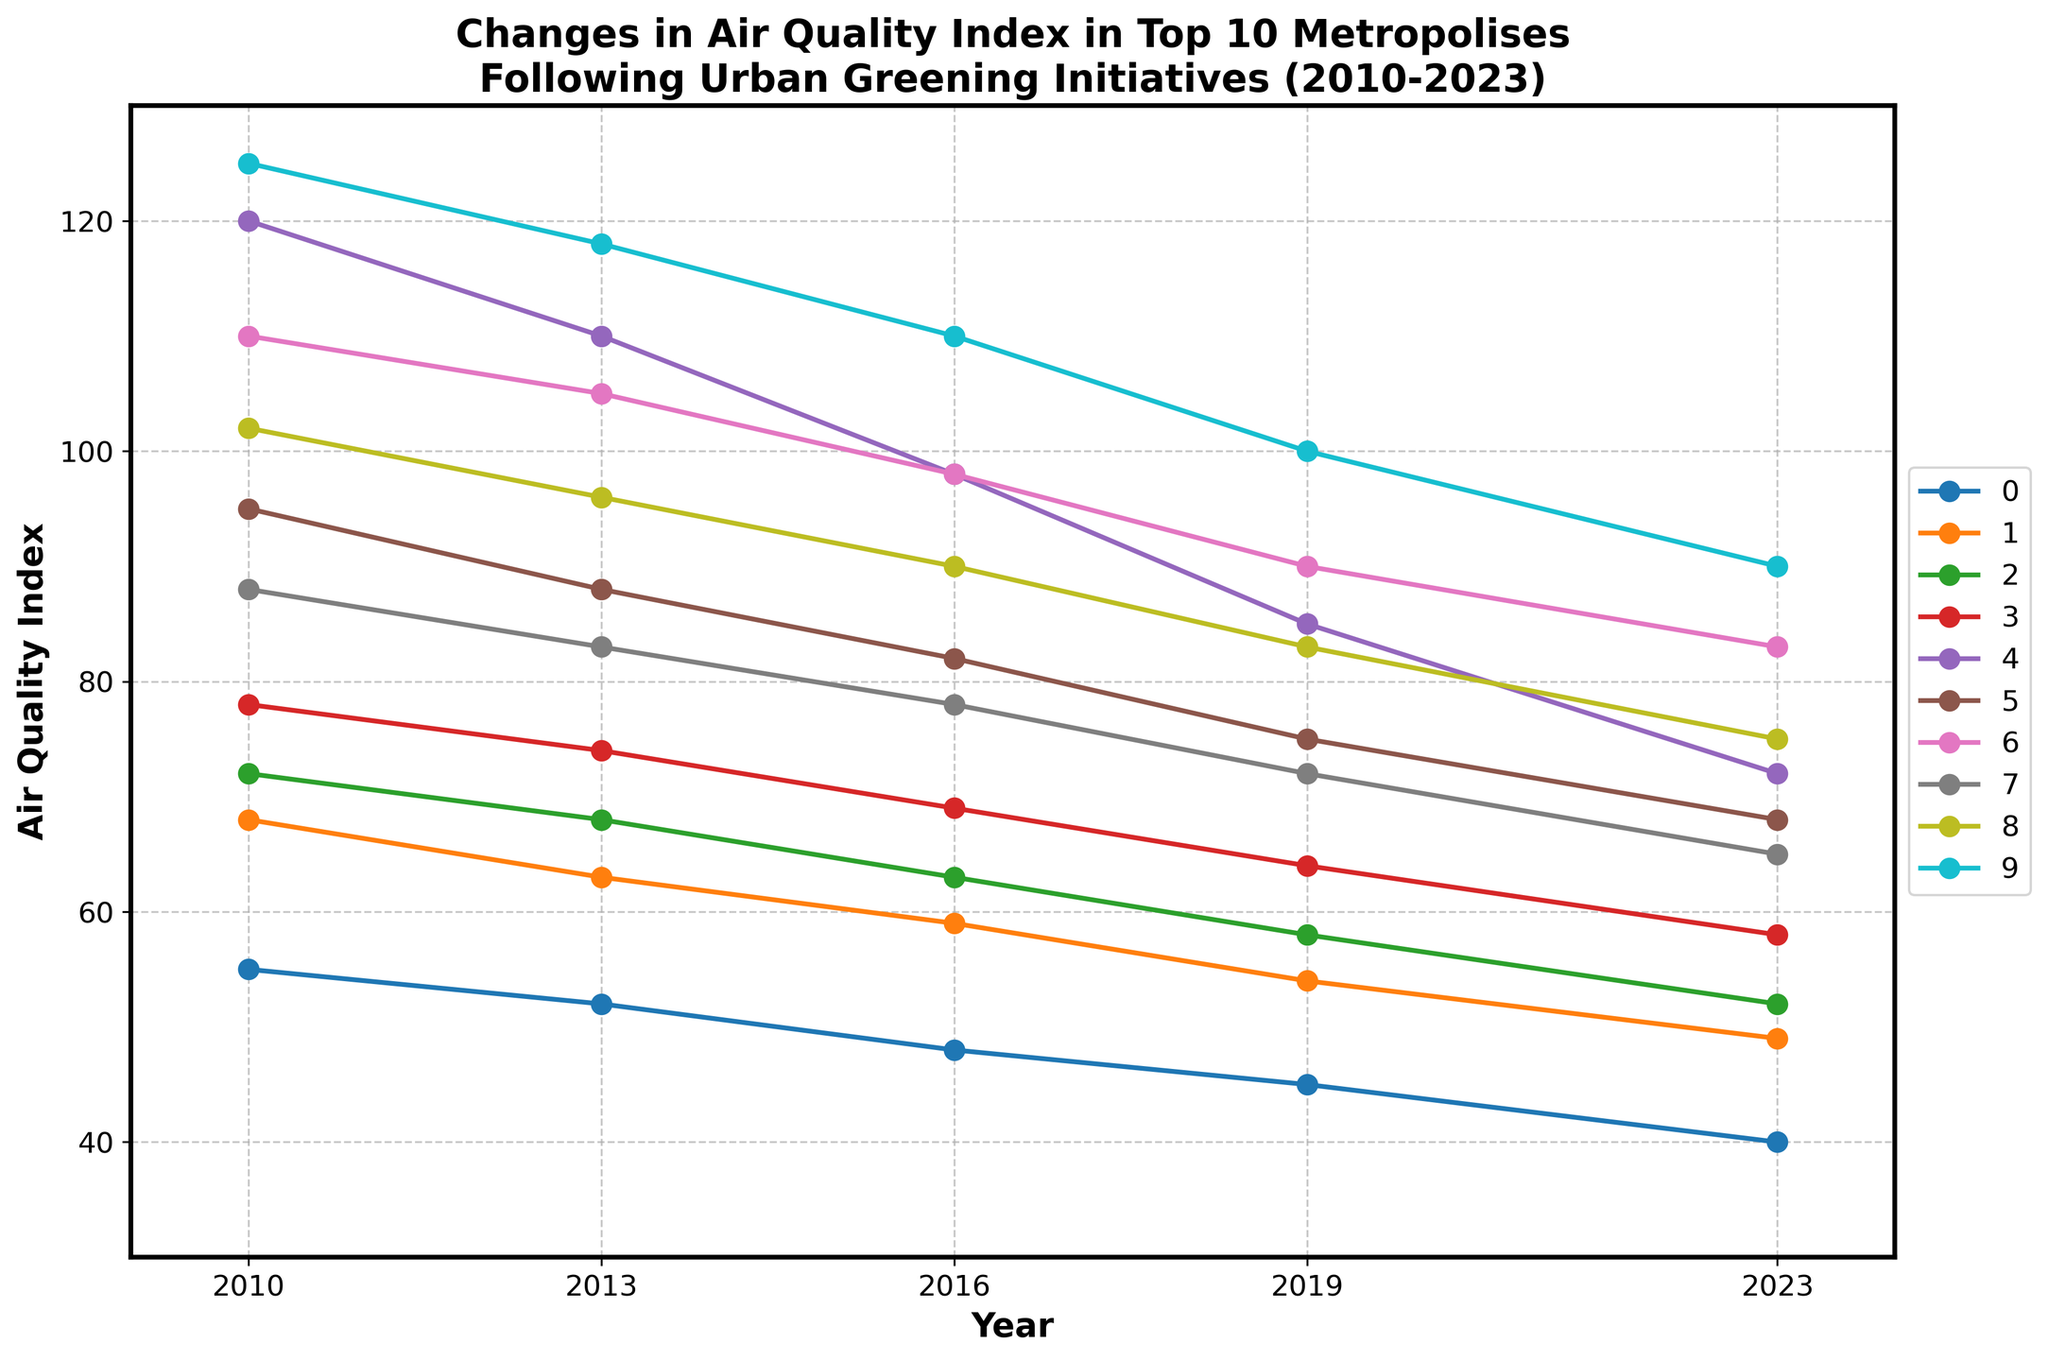Which city shows the most significant improvement in air quality index from 2010 to 2023? By analyzing the figure, find the largest difference in the air quality index between 2010 and 2023. Compare these differences for all cities.
Answer: Delhi Which city had the highest air quality index in 2010 and what was its value? Look for the tallest line at the 2010 mark on the figure. The city with the highest line represents the highest air quality index in 2010.
Answer: Delhi, 125 Which city had the lowest air quality index in 2023? Find the shortest line at the 2023 mark on the figure. The city with the lowest line represents the lowest air quality index in 2023.
Answer: Tokyo What is the difference in air quality index between Paris and São Paulo in 2023? Locate the values for Paris and São Paulo at the 2023 mark and subtract the smaller value from the larger value.
Answer: 7 How many cities had an air quality index above 80 in 2010 and below 80 in 2023? Identify the cities with values above 80 in 2010 and check if those cities had values below 80 in 2023. Count the qualifying cities.
Answer: 4 (Beijing, Shanghai, Mumbai, Mexico City) Which two cities show parallel trends over the years 2010 to 2023? Look for cities with lines that have similar slopes and shapes throughout the plotted years.
Answer: New York City and London How much did the air quality index for Mumbai change from 2016 to 2023? Identify Mumbai's air quality index values at 2016 and 2023 and calculate the difference.
Answer: 15 (98 - 83) Which city had a steeper decline in its air quality index between 2010 and 2016, London or New York City? Calculate the slope of the decline for both cities from 2010 to 2016 and compare.
Answer: London What is the average air quality index for Tokyo between 2010 and 2023? Sum Tokyo’s values across the years and divide by the number of values. \( (55 + 52 + 48 + 45 + 40)/5 \) = 48
Answer: 48 